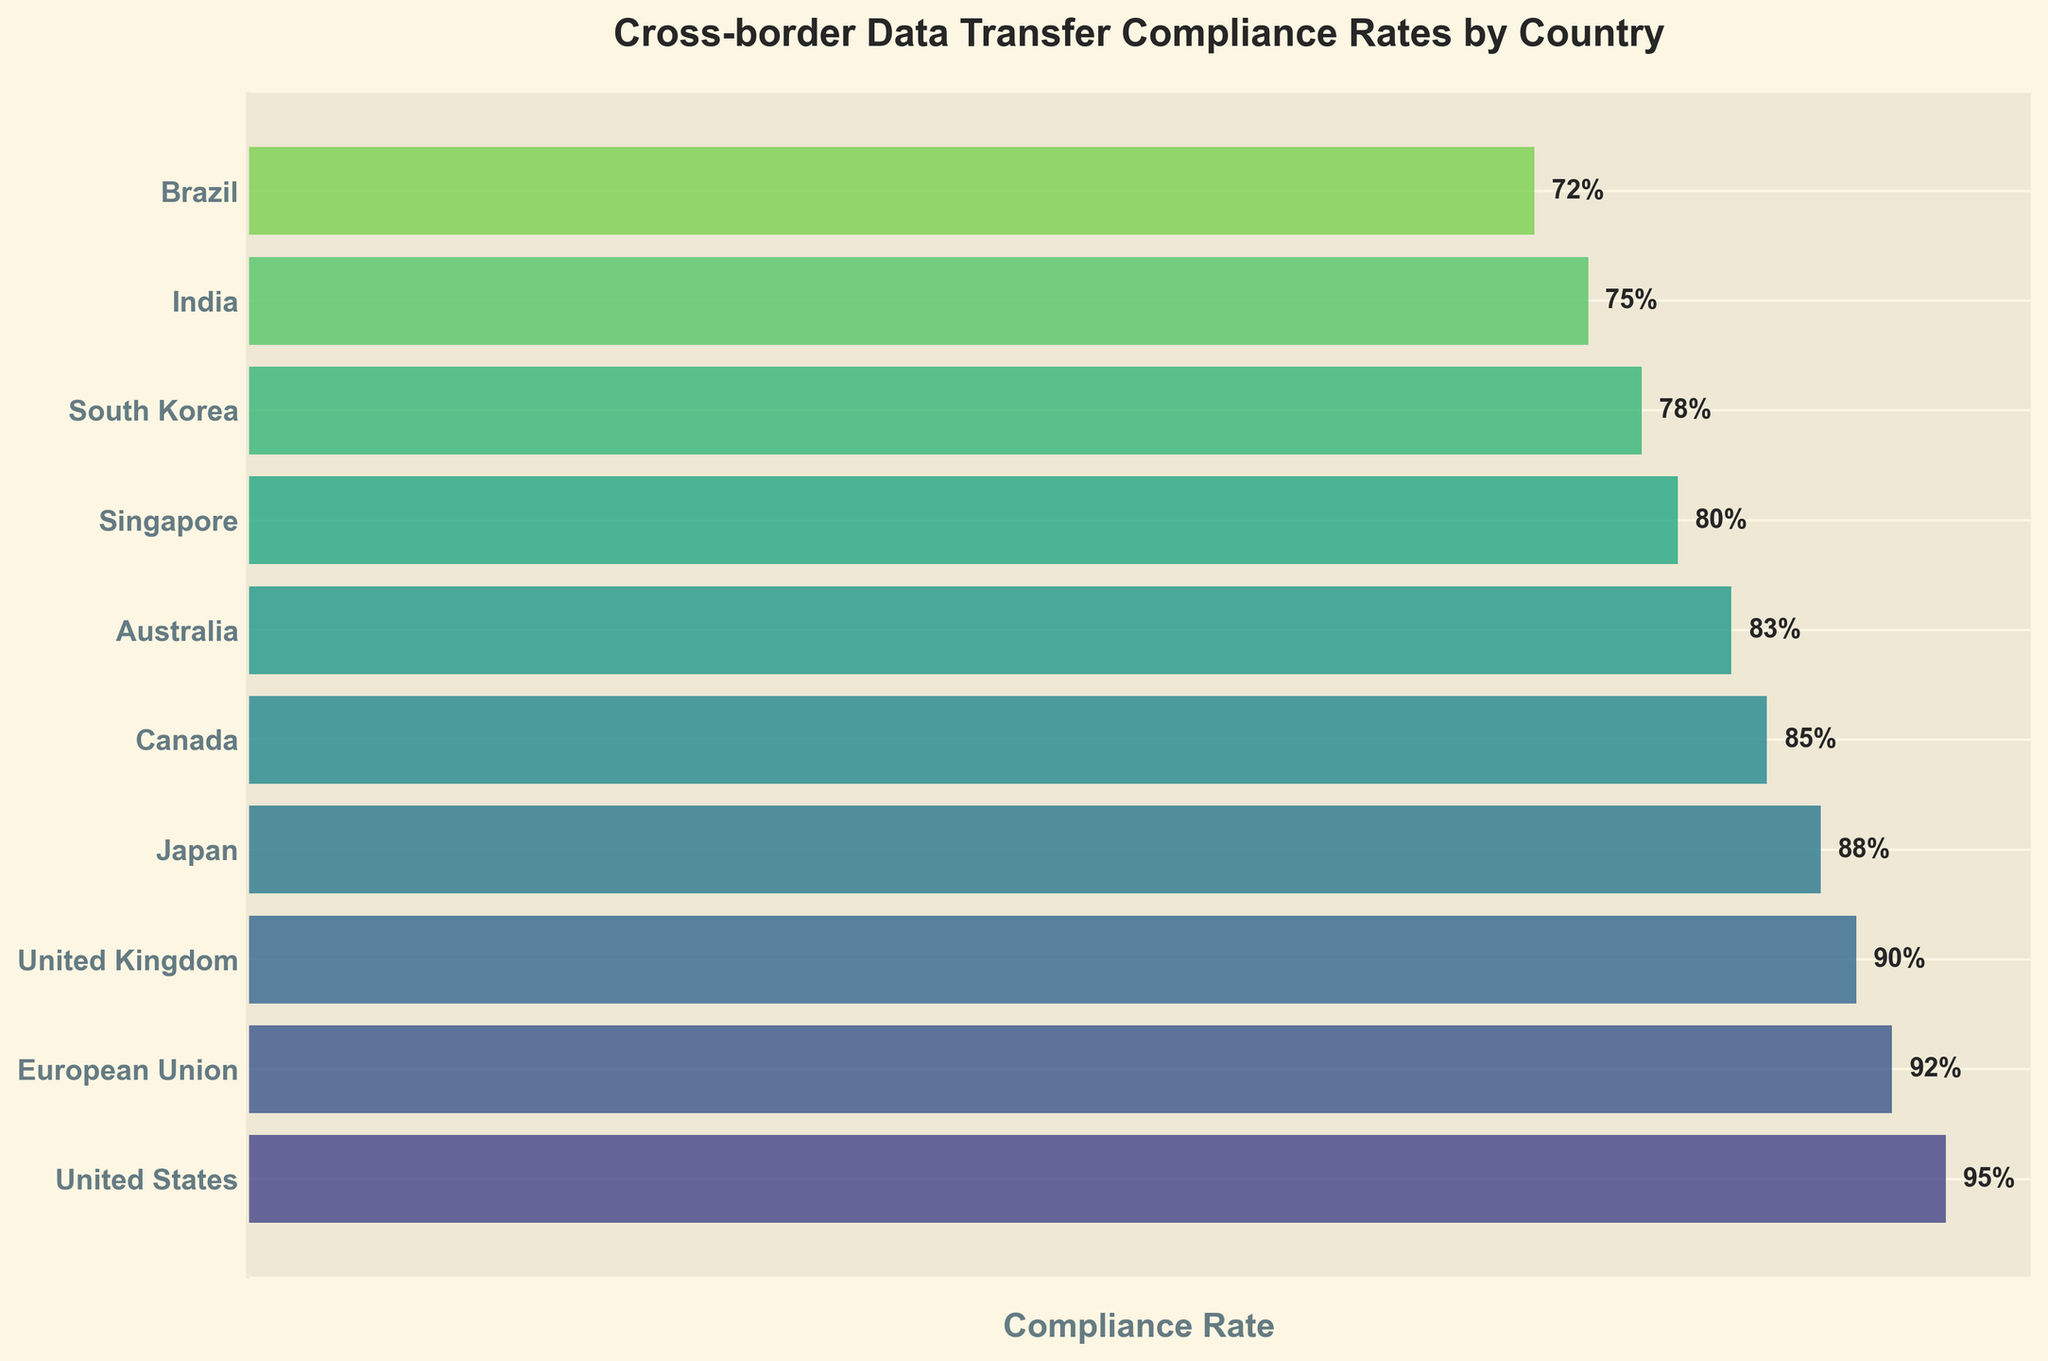What is the compliance rate for Japan? Look at the bar labeled 'Japan' and read the percentage label.
Answer: 88% Which country has the highest compliance rate? Find the bar with the longest width and highest percentage label. The United States has a rate of 95%.
Answer: United States How many countries have a compliance rate of 80% or above? Count the number of bars/data points with percentage labels 80% or higher. There are 7 such countries: United States, European Union, United Kingdom, Japan, Canada, Australia, and Singapore.
Answer: 7 What is the title of the funnel chart? Read the text at the top of the chart that describes the overall content.
Answer: Cross-border Data Transfer Compliance Rates by Country What is the compliance rate difference between the country with the highest rate and the country with the lowest rate? Subtract the lowest compliance rate (Brazil, 72%) from the highest compliance rate (United States, 95%). 95% - 72% = 23%
Answer: 23% Which countries have a compliance rate lower than 85%? List all countries with percentage labels less than 85%. These countries are Australia, Singapore, South Korea, India, and Brazil.
Answer: Australia, Singapore, South Korea, India, Brazil What is the average compliance rate of the countries listed? Add all compliance rates and divide by the number of countries. Total sum: 95 + 92 + 90 + 88 + 85 + 83 + 80 + 78 + 75 + 72 = 838. 838 / 10 = 83.8%
Answer: 83.8% Which region has similar compliance rates between 90% to 95%? Look for neighboring or logically grouped regions in the compliance range of 90% to 95%. The United States, European Union, and United Kingdom fall within this range.
Answer: United States, European Union, United Kingdom What two countries have the closest compliance rates? Compare the compliance rates of all countries to find the smallest difference. The closest compliance rates are between Canada (85%) and Australia (83%); difference is 2%.
Answer: Canada and Australia If a country has a compliance improvement plan aiming for at least 90%, how many countries need to improve to reach this target? Count the number of countries with compliance rates below 90%. These are Japan, Canada, Australia, Singapore, South Korea, India, and Brazil.
Answer: 7 